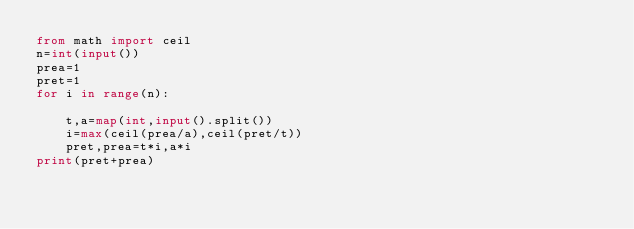Convert code to text. <code><loc_0><loc_0><loc_500><loc_500><_Python_>from math import ceil
n=int(input())
prea=1
pret=1
for i in range(n):
    
    t,a=map(int,input().split())
    i=max(ceil(prea/a),ceil(pret/t))
    pret,prea=t*i,a*i
print(pret+prea)</code> 